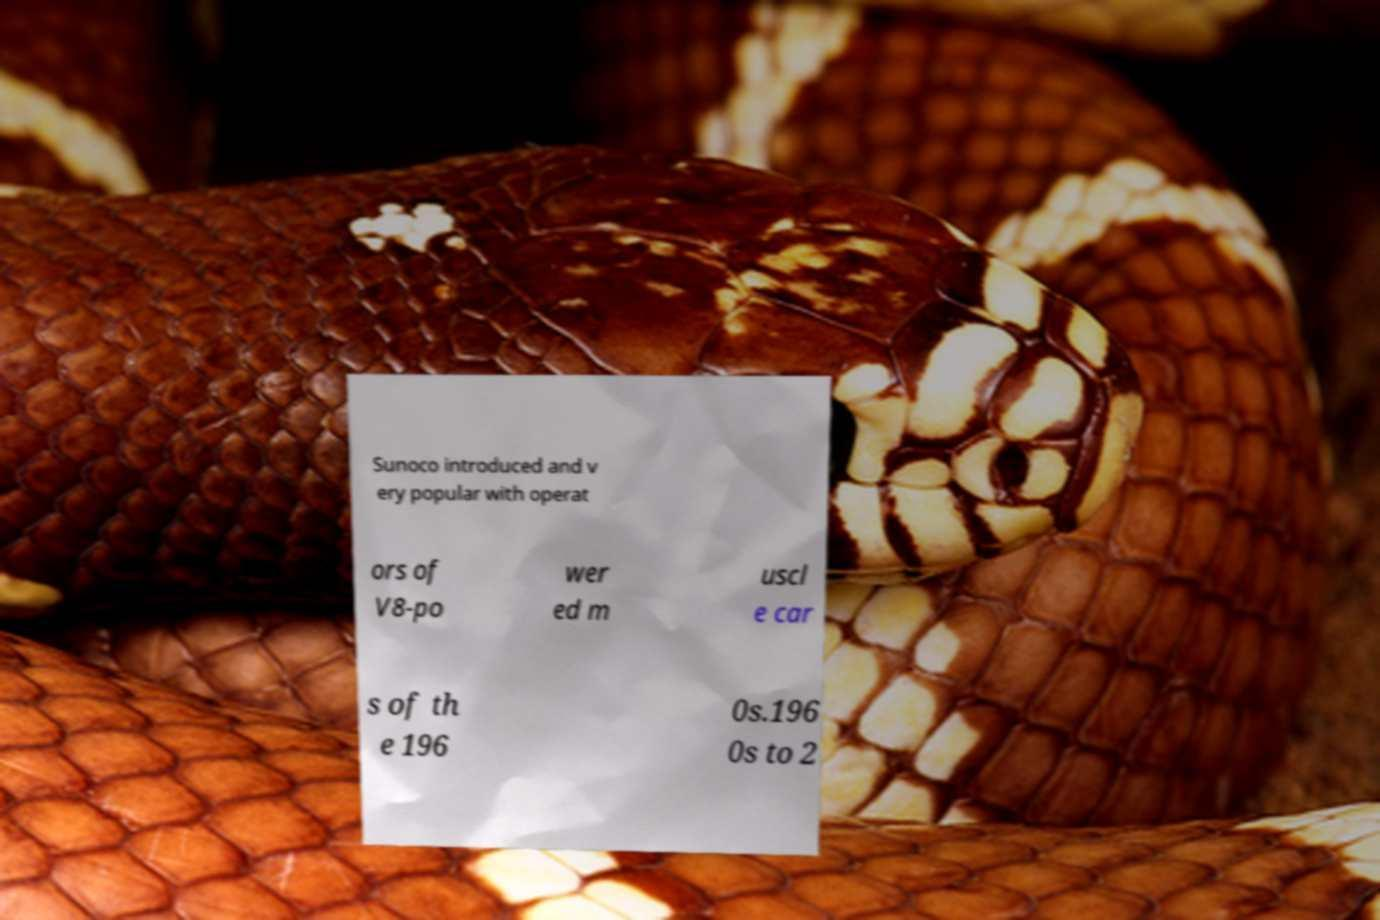Can you read and provide the text displayed in the image?This photo seems to have some interesting text. Can you extract and type it out for me? Sunoco introduced and v ery popular with operat ors of V8-po wer ed m uscl e car s of th e 196 0s.196 0s to 2 